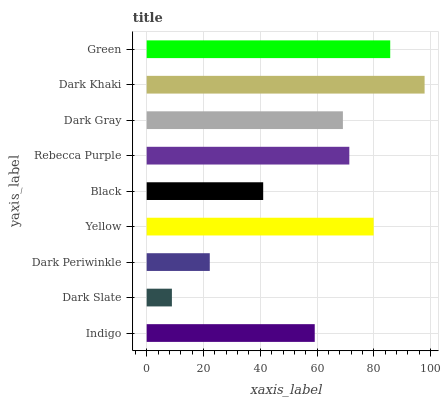Is Dark Slate the minimum?
Answer yes or no. Yes. Is Dark Khaki the maximum?
Answer yes or no. Yes. Is Dark Periwinkle the minimum?
Answer yes or no. No. Is Dark Periwinkle the maximum?
Answer yes or no. No. Is Dark Periwinkle greater than Dark Slate?
Answer yes or no. Yes. Is Dark Slate less than Dark Periwinkle?
Answer yes or no. Yes. Is Dark Slate greater than Dark Periwinkle?
Answer yes or no. No. Is Dark Periwinkle less than Dark Slate?
Answer yes or no. No. Is Dark Gray the high median?
Answer yes or no. Yes. Is Dark Gray the low median?
Answer yes or no. Yes. Is Dark Slate the high median?
Answer yes or no. No. Is Indigo the low median?
Answer yes or no. No. 